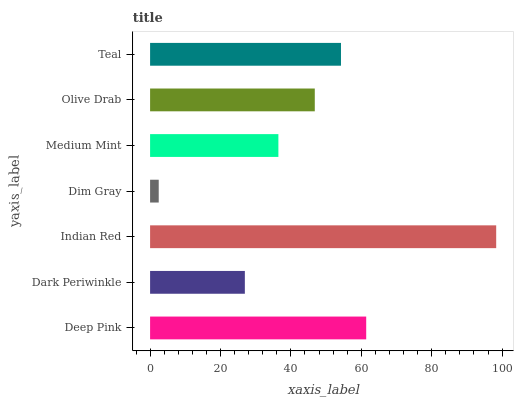Is Dim Gray the minimum?
Answer yes or no. Yes. Is Indian Red the maximum?
Answer yes or no. Yes. Is Dark Periwinkle the minimum?
Answer yes or no. No. Is Dark Periwinkle the maximum?
Answer yes or no. No. Is Deep Pink greater than Dark Periwinkle?
Answer yes or no. Yes. Is Dark Periwinkle less than Deep Pink?
Answer yes or no. Yes. Is Dark Periwinkle greater than Deep Pink?
Answer yes or no. No. Is Deep Pink less than Dark Periwinkle?
Answer yes or no. No. Is Olive Drab the high median?
Answer yes or no. Yes. Is Olive Drab the low median?
Answer yes or no. Yes. Is Medium Mint the high median?
Answer yes or no. No. Is Indian Red the low median?
Answer yes or no. No. 